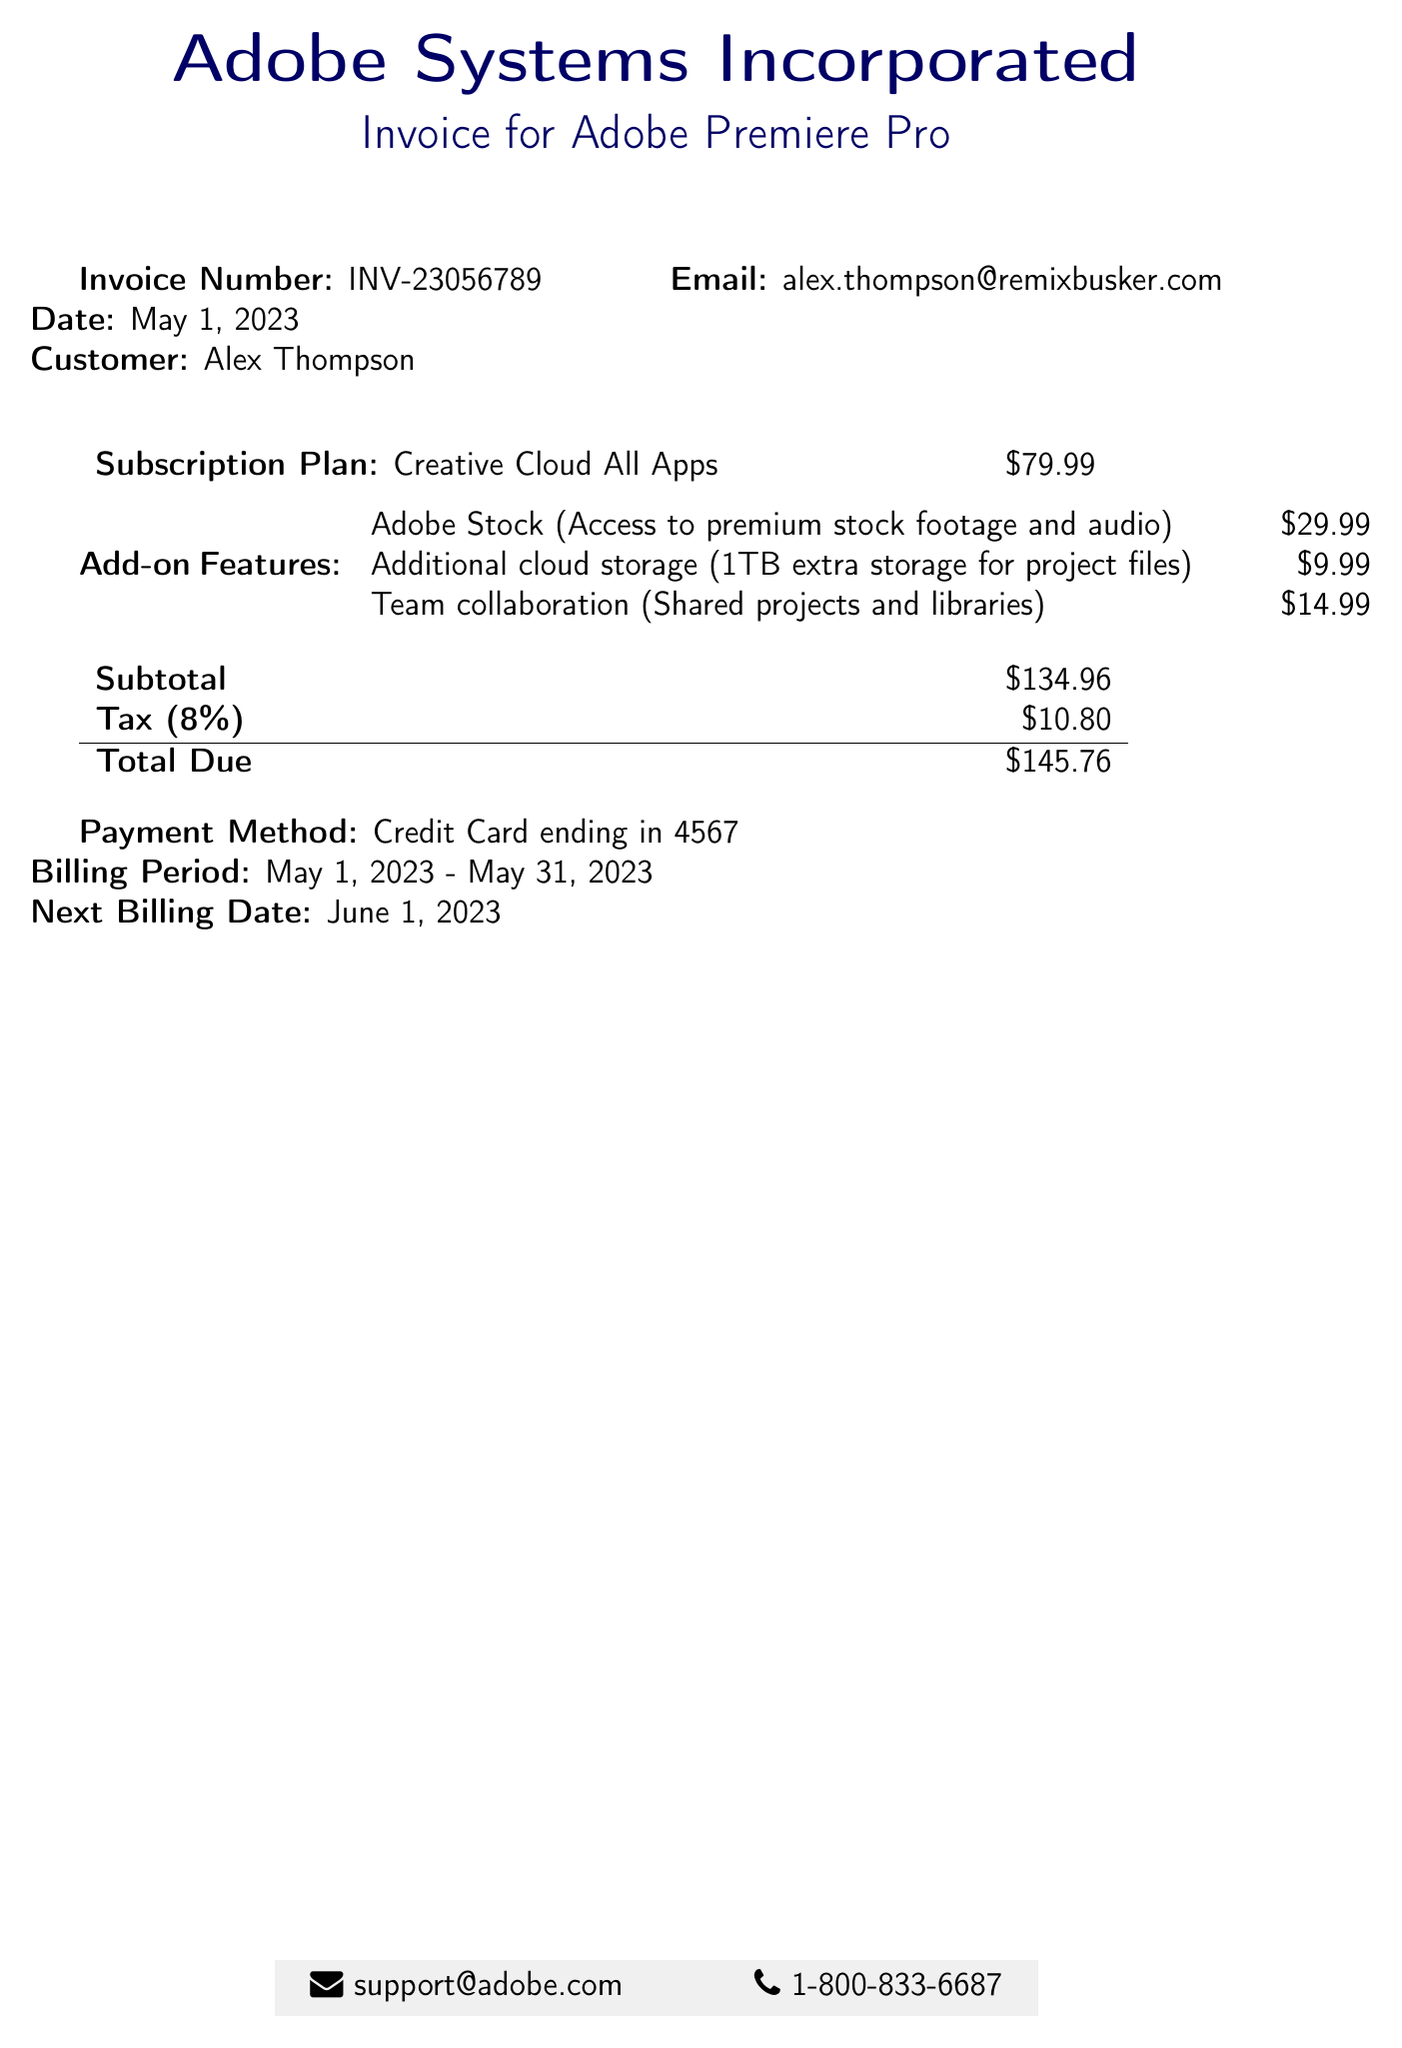what is the invoice number? The invoice number is a unique identifier for the bill, which is stated clearly in the document.
Answer: INV-23056789 who is the customer? The customer’s name is provided at the top section of the invoice.
Answer: Alex Thompson what is the total due? The total due is the final amount that must be paid, which is calculated in the document.
Answer: $145.76 what is the monthly subscription plan? The monthly subscription plan is specified in the main section of the invoice.
Answer: Creative Cloud All Apps how much is the charge for Adobe Stock? The charge for Adobe Stock is detailed in the add-on features section of the document.
Answer: $29.99 what is the tax percentage applied? The document states the tax percentage used for the total calculation.
Answer: 8% what is the billing period? The billing period indicates the time span covered by the invoice, mentioned clearly in the document.
Answer: May 1, 2023 - May 31, 2023 when is the next billing date? The next billing date is specified at the bottom of the invoice, indicating when the next payment is due.
Answer: June 1, 2023 what payment method was used? The payment method specifies how the payment was made, which is mentioned in the invoice.
Answer: Credit Card ending in 4567 